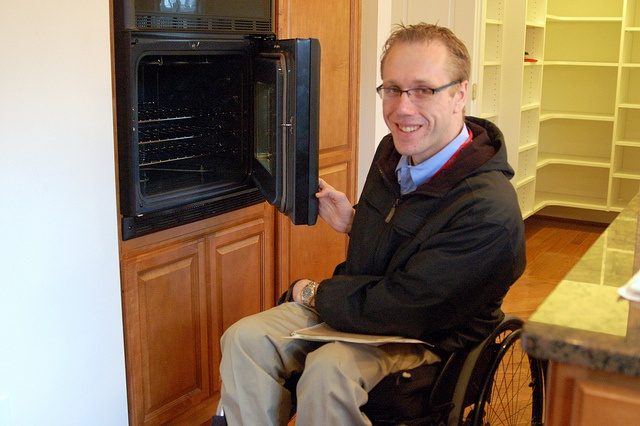Describe the objects in this image and their specific colors. I can see people in lightgray, black, darkgray, and tan tones and oven in lightgray, black, gray, and maroon tones in this image. 